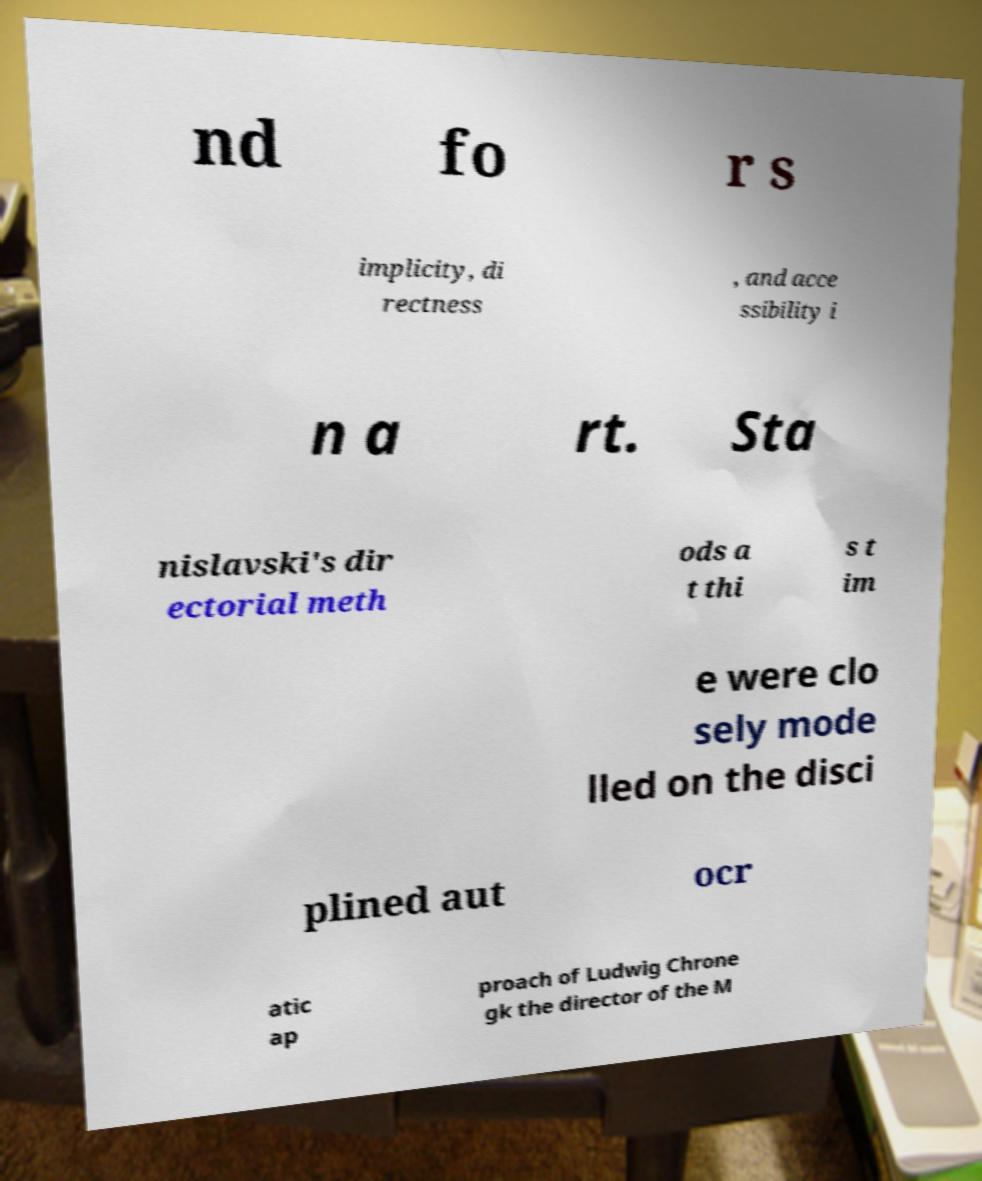I need the written content from this picture converted into text. Can you do that? nd fo r s implicity, di rectness , and acce ssibility i n a rt. Sta nislavski's dir ectorial meth ods a t thi s t im e were clo sely mode lled on the disci plined aut ocr atic ap proach of Ludwig Chrone gk the director of the M 